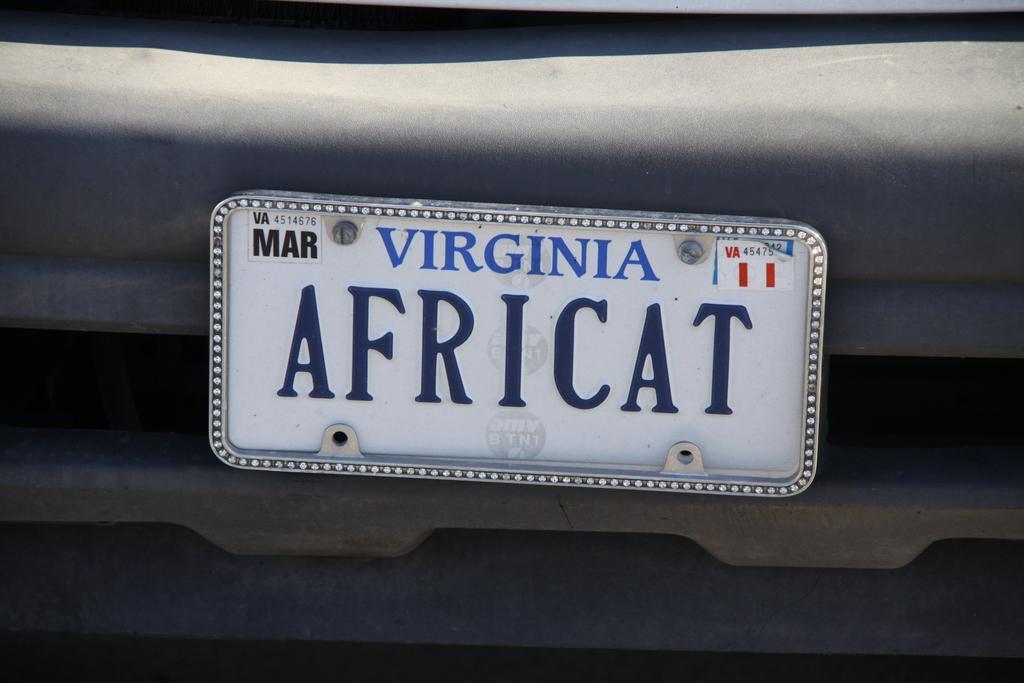Please provide a concise description of this image. In the image in the center, we can see one vehicle and banner. On the banner, it is written as "Africat". 